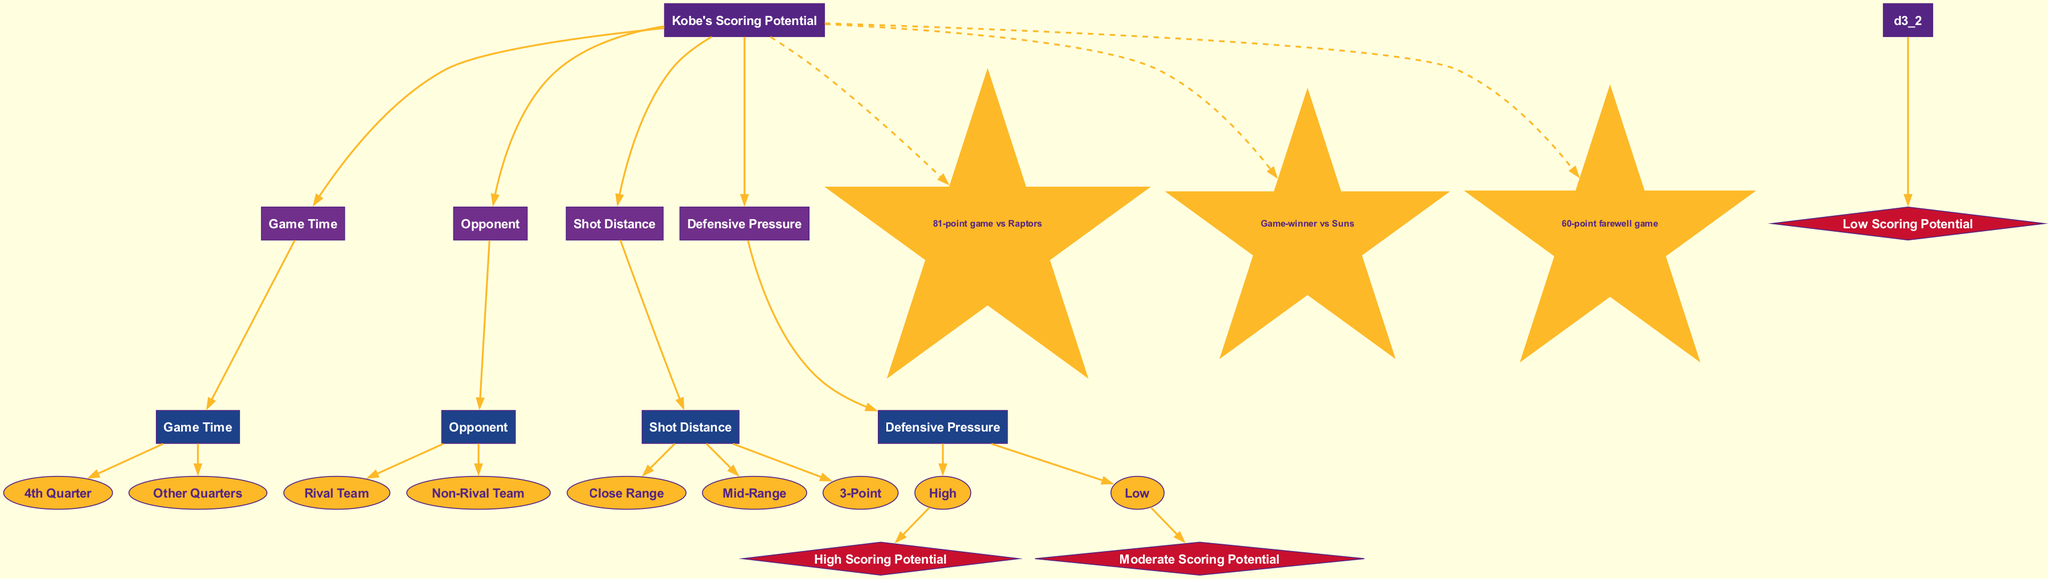What is the root node of the diagram? The root node is defined as the starting point of the decision tree. In this case, it is labeled "Kobe's Scoring Potential."
Answer: Kobe's Scoring Potential How many features are considered in the decision tree? The diagram lists four features that impact Kobe's scoring potential: Game Time, Opponent, Shot Distance, and Defensive Pressure. This totals to four features considered.
Answer: 4 What are the branches under the "Game Time" decision node? The "Game Time" decision node has two branches: "4th Quarter" and "Other Quarters." These branches divide the game time into two distinct temporal categories influencing scoring potential.
Answer: 4th Quarter, Other Quarters Which outcome follows from "Close Range" under "Defensive Pressure: Low"? To determine this, we start from "Close Range," then identify the flow down to the outcome node under "Defensive Pressure" set to "Low." The outcome reached is "High Scoring Potential."
Answer: High Scoring Potential What is the color of the nodes representing "iconic moments"? The diagram characterizes the iconic moments using star-shaped nodes and their color is defined as "gold" (or a similar bright shade) indicated by the fill color '#FDB927.'
Answer: gold If temperatures define outcomes, what would "3-Point" and "High" lead to? Beginning from the decision node "3-Point," we observe the branches leading to "Defensive Pressure." If the pressure is "High," we follow the connections through the decision path and find that this leads to "Low Scoring Potential."
Answer: Low Scoring Potential What is the total number of outcome nodes in the diagram? The diagram specifies three outcomes resulting from the decision-making process, which represent scoring potential levels. These outcomes are high, moderate, and low.
Answer: 3 Which feature has the highest number of branches? Evaluating the branches, the "Shot Distance" feature presents three distinct branches: "Close Range," "Mid-Range," and "3-Point," which is more than the other features that each have fewer branches.
Answer: Shot Distance Which branch leads to the "Moderate Scoring Potential"? Starting from the decision node "Shot Distance" leads to various pathways; however, the pathway that leads to "Moderate Scoring Potential" is via "Mid-Range" under low defensive pressure.
Answer: Mid-Range 